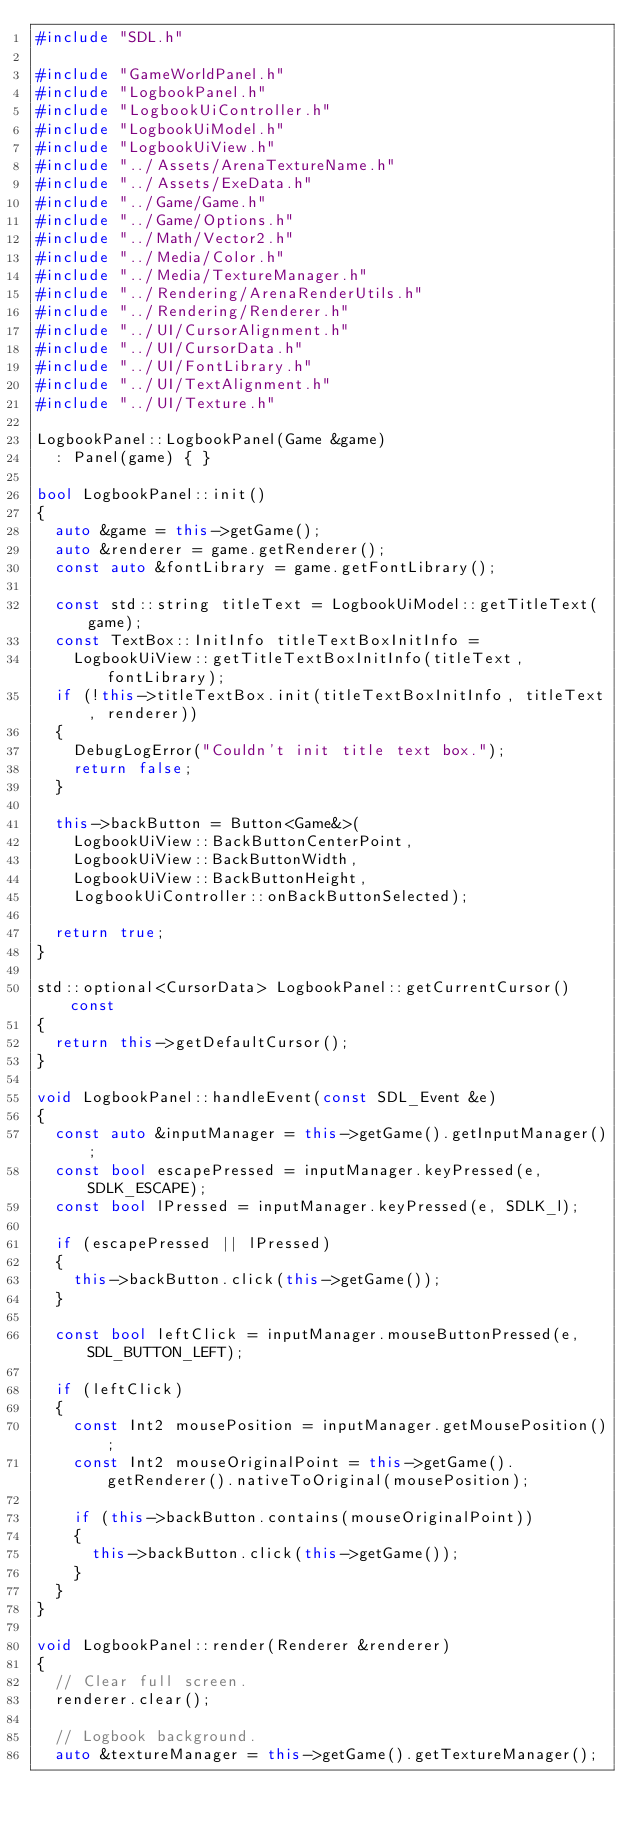<code> <loc_0><loc_0><loc_500><loc_500><_C++_>#include "SDL.h"

#include "GameWorldPanel.h"
#include "LogbookPanel.h"
#include "LogbookUiController.h"
#include "LogbookUiModel.h"
#include "LogbookUiView.h"
#include "../Assets/ArenaTextureName.h"
#include "../Assets/ExeData.h"
#include "../Game/Game.h"
#include "../Game/Options.h"
#include "../Math/Vector2.h"
#include "../Media/Color.h"
#include "../Media/TextureManager.h"
#include "../Rendering/ArenaRenderUtils.h"
#include "../Rendering/Renderer.h"
#include "../UI/CursorAlignment.h"
#include "../UI/CursorData.h"
#include "../UI/FontLibrary.h"
#include "../UI/TextAlignment.h"
#include "../UI/Texture.h"

LogbookPanel::LogbookPanel(Game &game)
	: Panel(game) { }

bool LogbookPanel::init()
{
	auto &game = this->getGame();
	auto &renderer = game.getRenderer();
	const auto &fontLibrary = game.getFontLibrary();

	const std::string titleText = LogbookUiModel::getTitleText(game);
	const TextBox::InitInfo titleTextBoxInitInfo =
		LogbookUiView::getTitleTextBoxInitInfo(titleText, fontLibrary);
	if (!this->titleTextBox.init(titleTextBoxInitInfo, titleText, renderer))
	{
		DebugLogError("Couldn't init title text box.");
		return false;
	}

	this->backButton = Button<Game&>(
		LogbookUiView::BackButtonCenterPoint,
		LogbookUiView::BackButtonWidth,
		LogbookUiView::BackButtonHeight,
		LogbookUiController::onBackButtonSelected);

	return true;
}

std::optional<CursorData> LogbookPanel::getCurrentCursor() const
{
	return this->getDefaultCursor();
}

void LogbookPanel::handleEvent(const SDL_Event &e)
{
	const auto &inputManager = this->getGame().getInputManager();
	const bool escapePressed = inputManager.keyPressed(e, SDLK_ESCAPE);
	const bool lPressed = inputManager.keyPressed(e, SDLK_l);

	if (escapePressed || lPressed)
	{
		this->backButton.click(this->getGame());
	}

	const bool leftClick = inputManager.mouseButtonPressed(e, SDL_BUTTON_LEFT);

	if (leftClick)
	{
		const Int2 mousePosition = inputManager.getMousePosition();
		const Int2 mouseOriginalPoint = this->getGame().getRenderer().nativeToOriginal(mousePosition);

		if (this->backButton.contains(mouseOriginalPoint))
		{
			this->backButton.click(this->getGame());
		}
	}
}

void LogbookPanel::render(Renderer &renderer)
{
	// Clear full screen.
	renderer.clear();

	// Logbook background.
	auto &textureManager = this->getGame().getTextureManager();</code> 